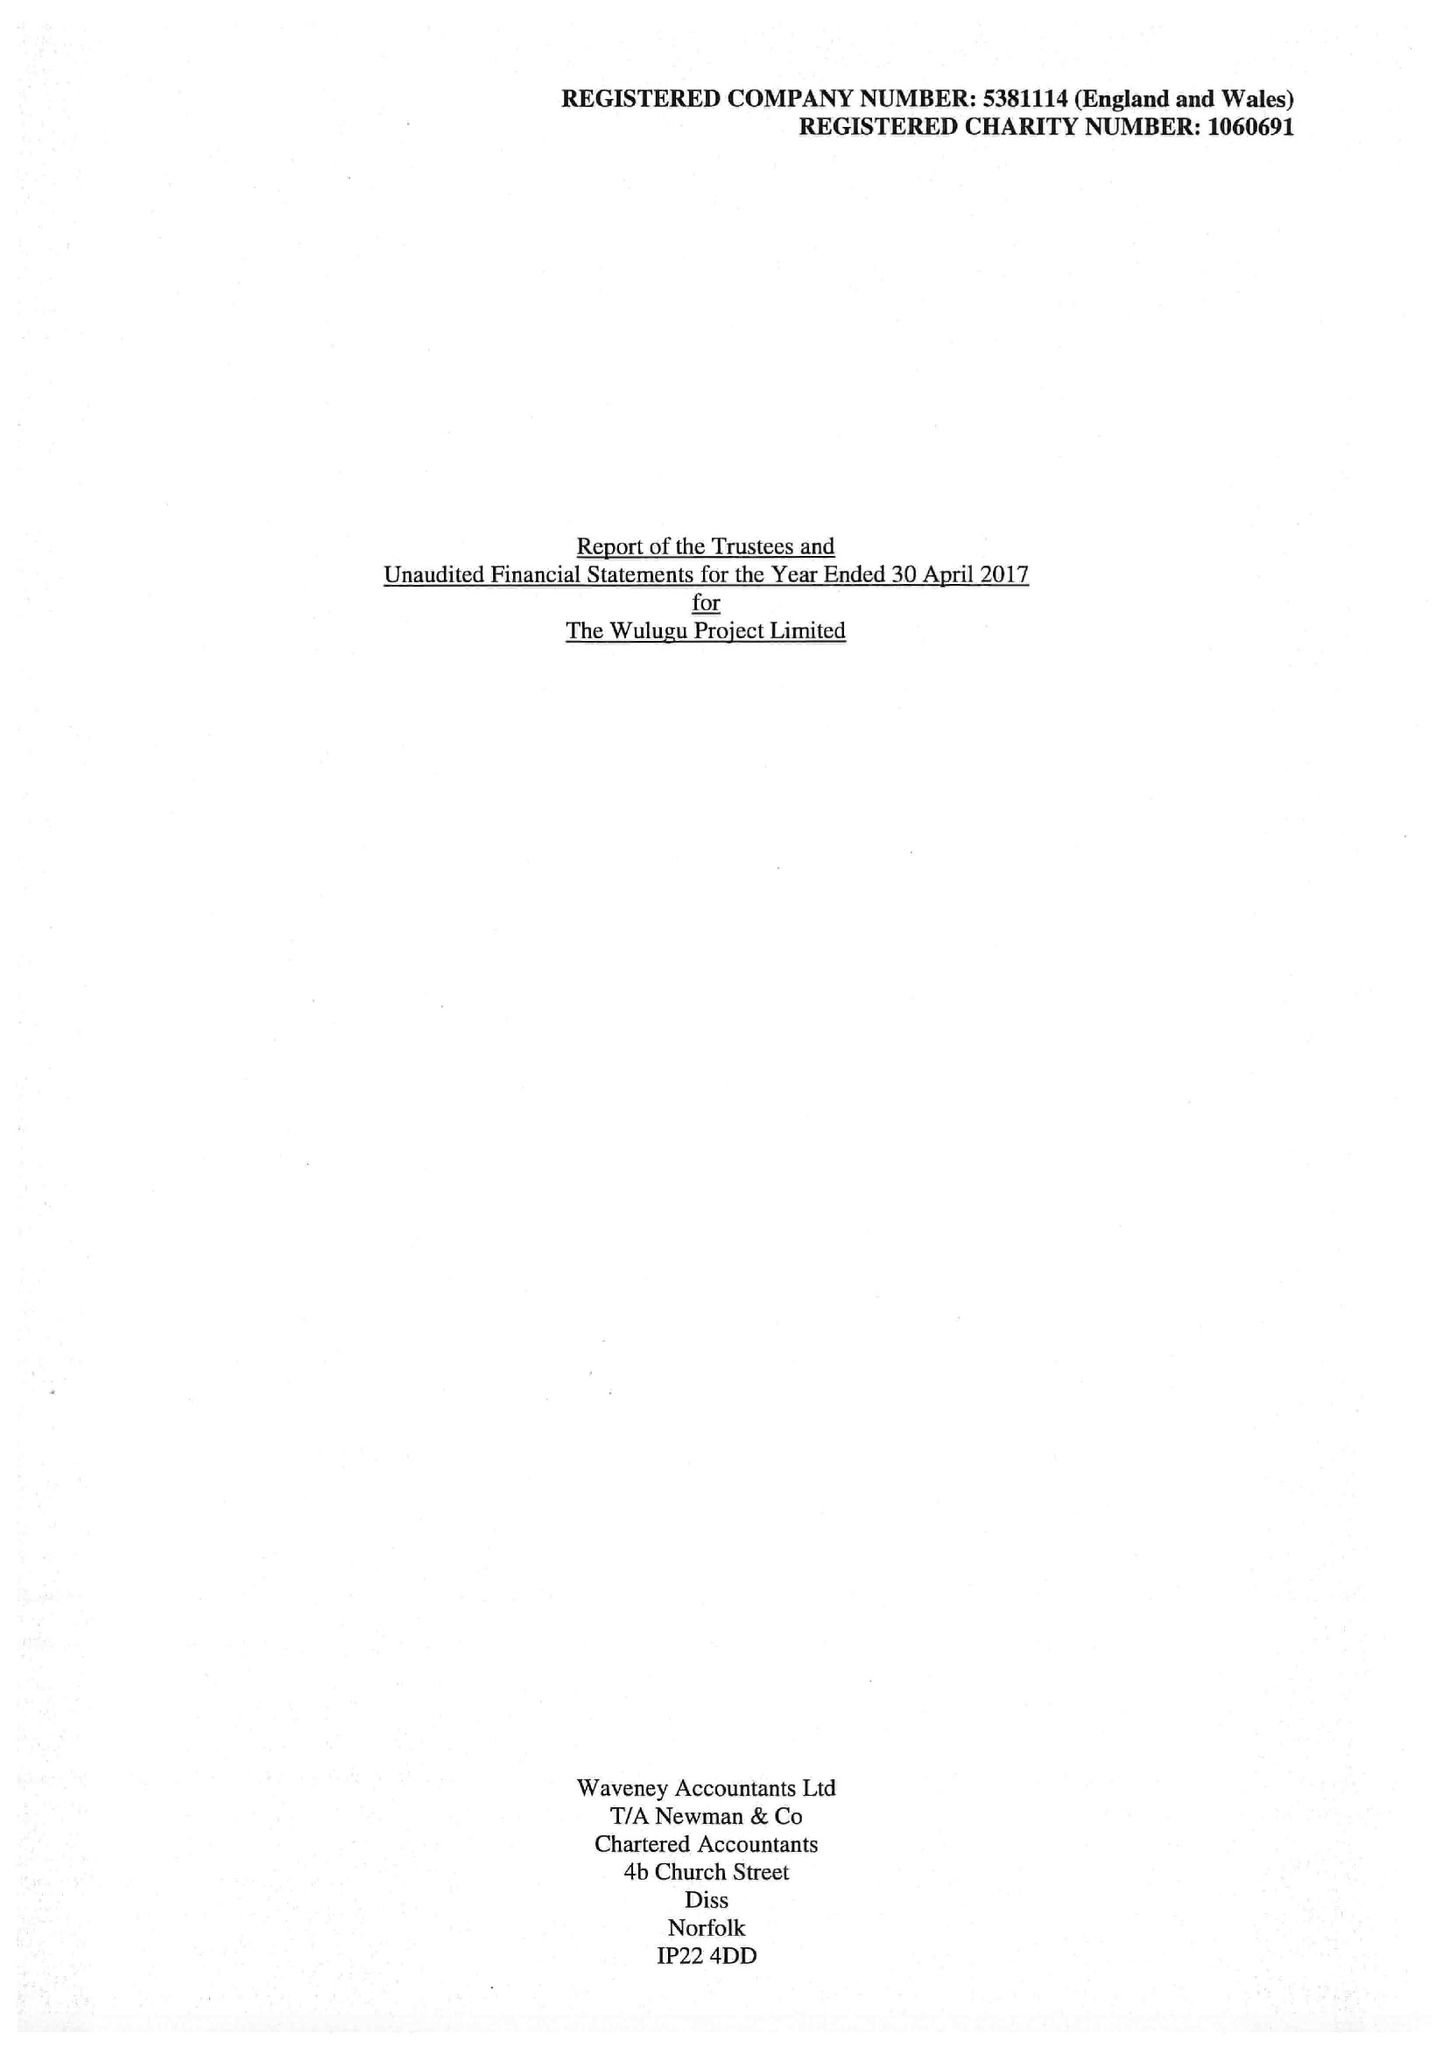What is the value for the charity_name?
Answer the question using a single word or phrase. The Wulugu Project 